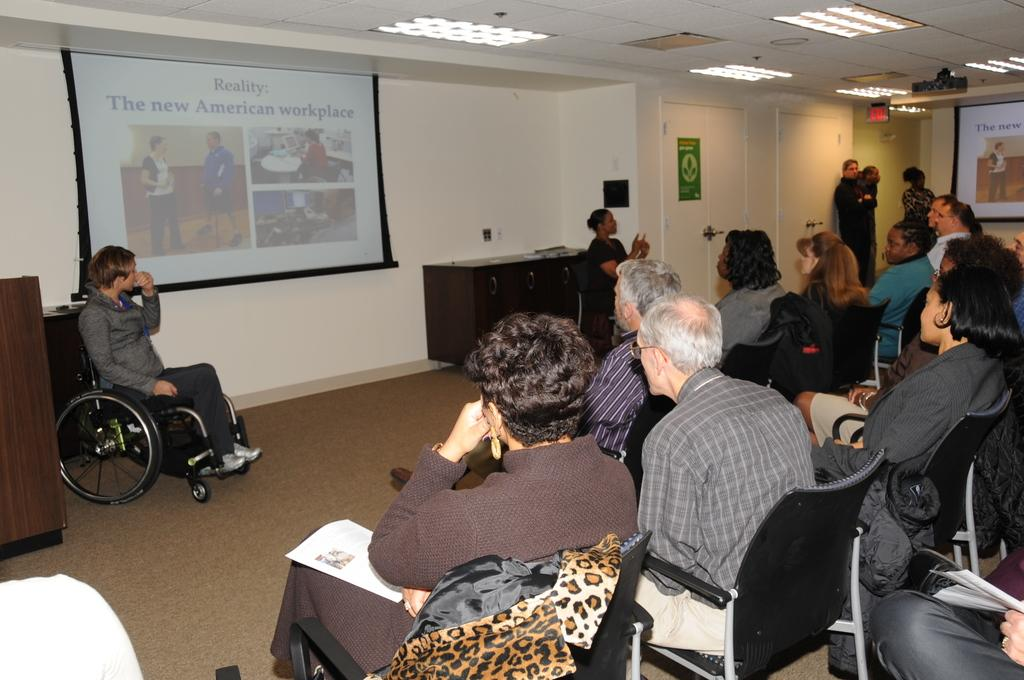What are the majority of people in the image doing? Most of the persons are sitting on chairs. What is on the wall in the image? There is a screen on the wall. Are there any people standing in the image? Yes, some persons are standing far from the sitting persons. What type of furniture can be seen in the image? There is a cupboard in the image. What is the feeling of the value of the stop in the image? There is no mention of feelings, values, or stops in the image; it primarily features people sitting on chairs, a screen on the wall, standing persons, and a cupboard. 